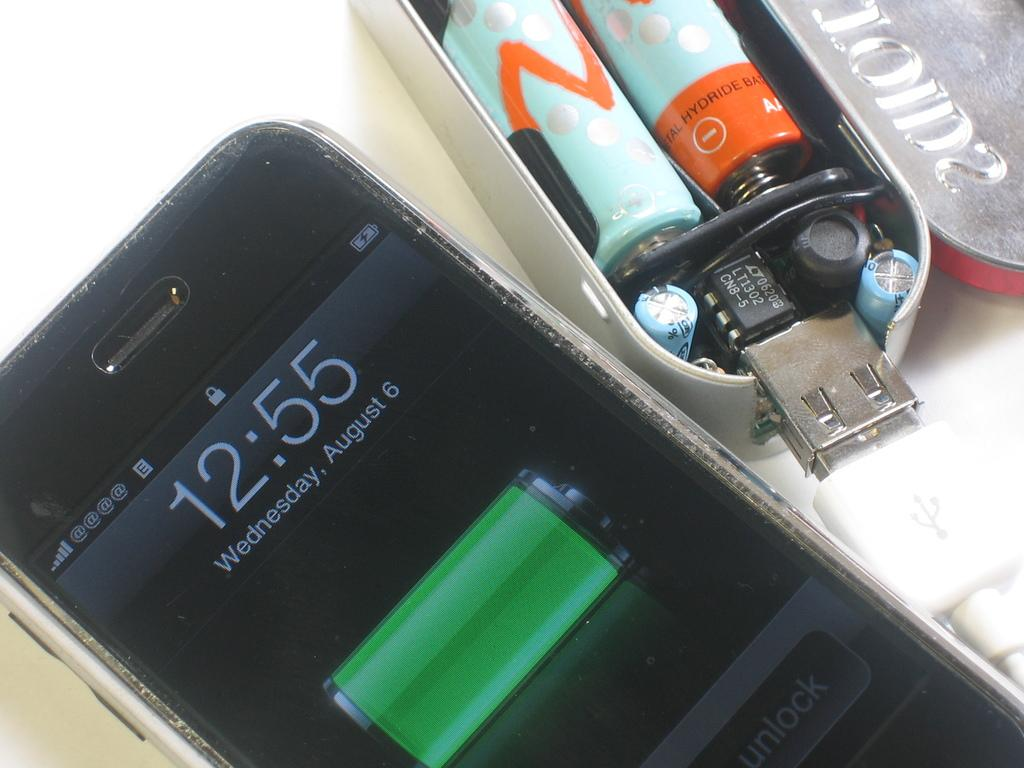Provide a one-sentence caption for the provided image. The phone screen displays a time of 12:55. 